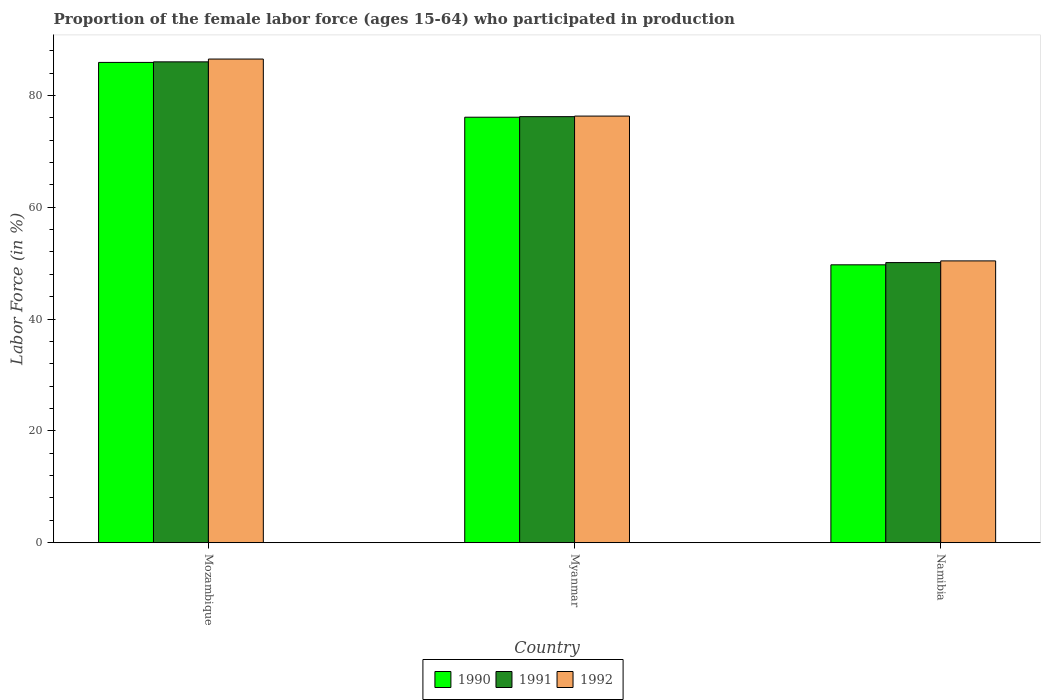How many bars are there on the 2nd tick from the left?
Give a very brief answer. 3. What is the label of the 2nd group of bars from the left?
Provide a succinct answer. Myanmar. What is the proportion of the female labor force who participated in production in 1992 in Namibia?
Offer a very short reply. 50.4. Across all countries, what is the maximum proportion of the female labor force who participated in production in 1992?
Offer a terse response. 86.5. Across all countries, what is the minimum proportion of the female labor force who participated in production in 1990?
Provide a succinct answer. 49.7. In which country was the proportion of the female labor force who participated in production in 1992 maximum?
Offer a very short reply. Mozambique. In which country was the proportion of the female labor force who participated in production in 1991 minimum?
Ensure brevity in your answer.  Namibia. What is the total proportion of the female labor force who participated in production in 1990 in the graph?
Ensure brevity in your answer.  211.7. What is the difference between the proportion of the female labor force who participated in production in 1991 in Mozambique and that in Namibia?
Offer a terse response. 35.9. What is the difference between the proportion of the female labor force who participated in production in 1990 in Mozambique and the proportion of the female labor force who participated in production in 1991 in Myanmar?
Make the answer very short. 9.7. What is the average proportion of the female labor force who participated in production in 1992 per country?
Your answer should be compact. 71.07. What is the difference between the proportion of the female labor force who participated in production of/in 1990 and proportion of the female labor force who participated in production of/in 1992 in Myanmar?
Provide a succinct answer. -0.2. What is the ratio of the proportion of the female labor force who participated in production in 1991 in Myanmar to that in Namibia?
Keep it short and to the point. 1.52. What is the difference between the highest and the second highest proportion of the female labor force who participated in production in 1992?
Give a very brief answer. -25.9. What is the difference between the highest and the lowest proportion of the female labor force who participated in production in 1990?
Your response must be concise. 36.2. What does the 1st bar from the left in Myanmar represents?
Make the answer very short. 1990. What does the 1st bar from the right in Mozambique represents?
Your answer should be very brief. 1992. Are the values on the major ticks of Y-axis written in scientific E-notation?
Your answer should be compact. No. Does the graph contain any zero values?
Offer a terse response. No. Does the graph contain grids?
Offer a terse response. No. Where does the legend appear in the graph?
Provide a short and direct response. Bottom center. How many legend labels are there?
Make the answer very short. 3. How are the legend labels stacked?
Provide a short and direct response. Horizontal. What is the title of the graph?
Your response must be concise. Proportion of the female labor force (ages 15-64) who participated in production. Does "1961" appear as one of the legend labels in the graph?
Make the answer very short. No. What is the label or title of the X-axis?
Offer a terse response. Country. What is the label or title of the Y-axis?
Provide a succinct answer. Labor Force (in %). What is the Labor Force (in %) of 1990 in Mozambique?
Keep it short and to the point. 85.9. What is the Labor Force (in %) in 1992 in Mozambique?
Make the answer very short. 86.5. What is the Labor Force (in %) in 1990 in Myanmar?
Offer a very short reply. 76.1. What is the Labor Force (in %) in 1991 in Myanmar?
Offer a very short reply. 76.2. What is the Labor Force (in %) in 1992 in Myanmar?
Offer a very short reply. 76.3. What is the Labor Force (in %) of 1990 in Namibia?
Your response must be concise. 49.7. What is the Labor Force (in %) in 1991 in Namibia?
Ensure brevity in your answer.  50.1. What is the Labor Force (in %) of 1992 in Namibia?
Give a very brief answer. 50.4. Across all countries, what is the maximum Labor Force (in %) of 1990?
Give a very brief answer. 85.9. Across all countries, what is the maximum Labor Force (in %) in 1991?
Keep it short and to the point. 86. Across all countries, what is the maximum Labor Force (in %) in 1992?
Your response must be concise. 86.5. Across all countries, what is the minimum Labor Force (in %) of 1990?
Offer a terse response. 49.7. Across all countries, what is the minimum Labor Force (in %) in 1991?
Keep it short and to the point. 50.1. Across all countries, what is the minimum Labor Force (in %) in 1992?
Provide a short and direct response. 50.4. What is the total Labor Force (in %) in 1990 in the graph?
Your answer should be very brief. 211.7. What is the total Labor Force (in %) in 1991 in the graph?
Give a very brief answer. 212.3. What is the total Labor Force (in %) of 1992 in the graph?
Provide a succinct answer. 213.2. What is the difference between the Labor Force (in %) of 1991 in Mozambique and that in Myanmar?
Your answer should be compact. 9.8. What is the difference between the Labor Force (in %) in 1992 in Mozambique and that in Myanmar?
Offer a very short reply. 10.2. What is the difference between the Labor Force (in %) of 1990 in Mozambique and that in Namibia?
Make the answer very short. 36.2. What is the difference between the Labor Force (in %) of 1991 in Mozambique and that in Namibia?
Ensure brevity in your answer.  35.9. What is the difference between the Labor Force (in %) of 1992 in Mozambique and that in Namibia?
Offer a very short reply. 36.1. What is the difference between the Labor Force (in %) of 1990 in Myanmar and that in Namibia?
Offer a terse response. 26.4. What is the difference between the Labor Force (in %) of 1991 in Myanmar and that in Namibia?
Provide a succinct answer. 26.1. What is the difference between the Labor Force (in %) of 1992 in Myanmar and that in Namibia?
Your response must be concise. 25.9. What is the difference between the Labor Force (in %) in 1990 in Mozambique and the Labor Force (in %) in 1991 in Namibia?
Offer a very short reply. 35.8. What is the difference between the Labor Force (in %) in 1990 in Mozambique and the Labor Force (in %) in 1992 in Namibia?
Your answer should be very brief. 35.5. What is the difference between the Labor Force (in %) in 1991 in Mozambique and the Labor Force (in %) in 1992 in Namibia?
Offer a very short reply. 35.6. What is the difference between the Labor Force (in %) of 1990 in Myanmar and the Labor Force (in %) of 1992 in Namibia?
Your response must be concise. 25.7. What is the difference between the Labor Force (in %) in 1991 in Myanmar and the Labor Force (in %) in 1992 in Namibia?
Make the answer very short. 25.8. What is the average Labor Force (in %) of 1990 per country?
Provide a short and direct response. 70.57. What is the average Labor Force (in %) in 1991 per country?
Your answer should be very brief. 70.77. What is the average Labor Force (in %) in 1992 per country?
Make the answer very short. 71.07. What is the difference between the Labor Force (in %) of 1990 and Labor Force (in %) of 1991 in Mozambique?
Offer a terse response. -0.1. What is the difference between the Labor Force (in %) in 1991 and Labor Force (in %) in 1992 in Mozambique?
Your answer should be very brief. -0.5. What is the difference between the Labor Force (in %) in 1990 and Labor Force (in %) in 1991 in Myanmar?
Your answer should be compact. -0.1. What is the difference between the Labor Force (in %) in 1990 and Labor Force (in %) in 1992 in Myanmar?
Ensure brevity in your answer.  -0.2. What is the difference between the Labor Force (in %) in 1991 and Labor Force (in %) in 1992 in Namibia?
Ensure brevity in your answer.  -0.3. What is the ratio of the Labor Force (in %) of 1990 in Mozambique to that in Myanmar?
Ensure brevity in your answer.  1.13. What is the ratio of the Labor Force (in %) in 1991 in Mozambique to that in Myanmar?
Provide a short and direct response. 1.13. What is the ratio of the Labor Force (in %) in 1992 in Mozambique to that in Myanmar?
Make the answer very short. 1.13. What is the ratio of the Labor Force (in %) of 1990 in Mozambique to that in Namibia?
Provide a succinct answer. 1.73. What is the ratio of the Labor Force (in %) of 1991 in Mozambique to that in Namibia?
Offer a very short reply. 1.72. What is the ratio of the Labor Force (in %) in 1992 in Mozambique to that in Namibia?
Your answer should be very brief. 1.72. What is the ratio of the Labor Force (in %) of 1990 in Myanmar to that in Namibia?
Offer a terse response. 1.53. What is the ratio of the Labor Force (in %) of 1991 in Myanmar to that in Namibia?
Keep it short and to the point. 1.52. What is the ratio of the Labor Force (in %) in 1992 in Myanmar to that in Namibia?
Your answer should be very brief. 1.51. What is the difference between the highest and the second highest Labor Force (in %) of 1990?
Give a very brief answer. 9.8. What is the difference between the highest and the second highest Labor Force (in %) of 1992?
Your response must be concise. 10.2. What is the difference between the highest and the lowest Labor Force (in %) of 1990?
Give a very brief answer. 36.2. What is the difference between the highest and the lowest Labor Force (in %) in 1991?
Make the answer very short. 35.9. What is the difference between the highest and the lowest Labor Force (in %) of 1992?
Provide a short and direct response. 36.1. 